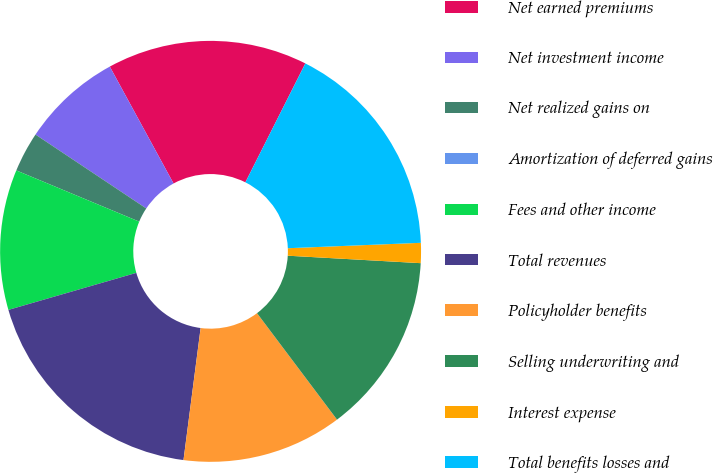Convert chart. <chart><loc_0><loc_0><loc_500><loc_500><pie_chart><fcel>Net earned premiums<fcel>Net investment income<fcel>Net realized gains on<fcel>Amortization of deferred gains<fcel>Fees and other income<fcel>Total revenues<fcel>Policyholder benefits<fcel>Selling underwriting and<fcel>Interest expense<fcel>Total benefits losses and<nl><fcel>15.38%<fcel>7.69%<fcel>3.08%<fcel>0.0%<fcel>10.77%<fcel>18.46%<fcel>12.31%<fcel>13.85%<fcel>1.54%<fcel>16.92%<nl></chart> 